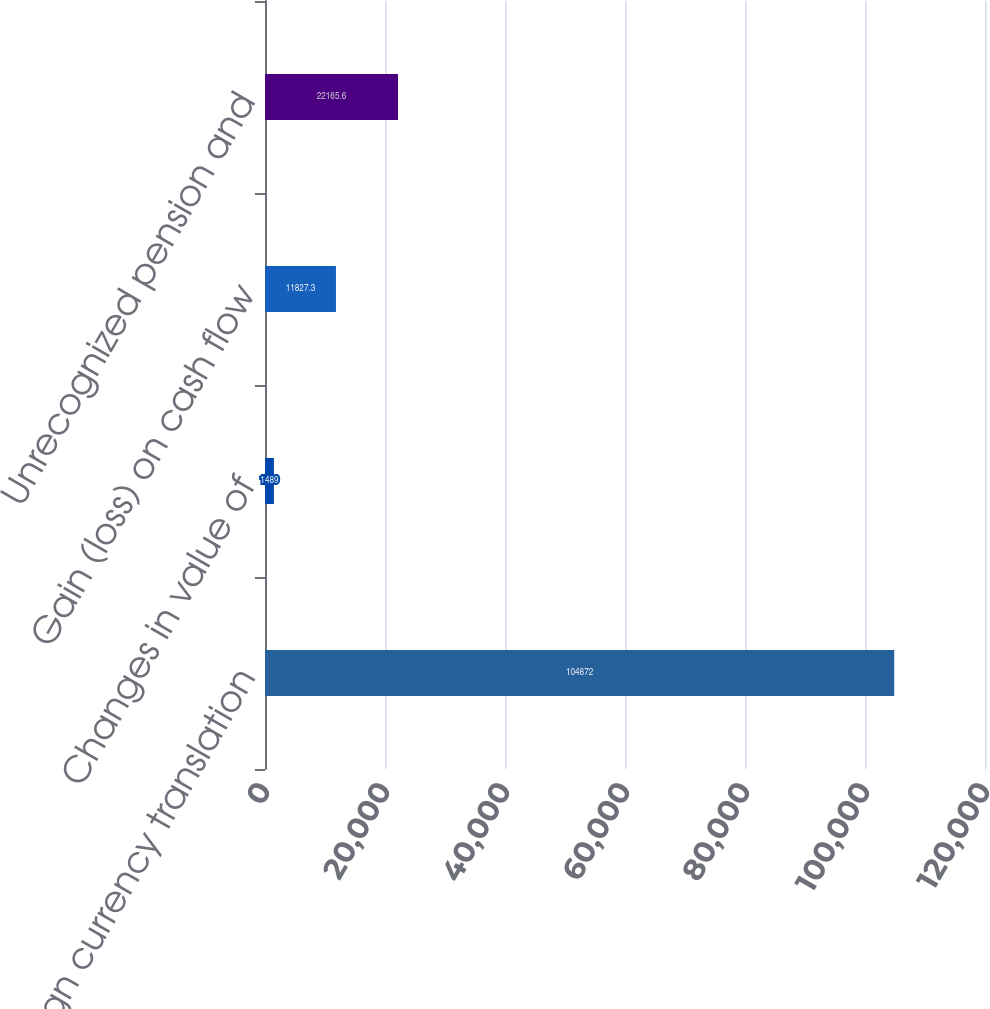Convert chart. <chart><loc_0><loc_0><loc_500><loc_500><bar_chart><fcel>Foreign currency translation<fcel>Changes in value of<fcel>Gain (loss) on cash flow<fcel>Unrecognized pension and<nl><fcel>104872<fcel>1489<fcel>11827.3<fcel>22165.6<nl></chart> 